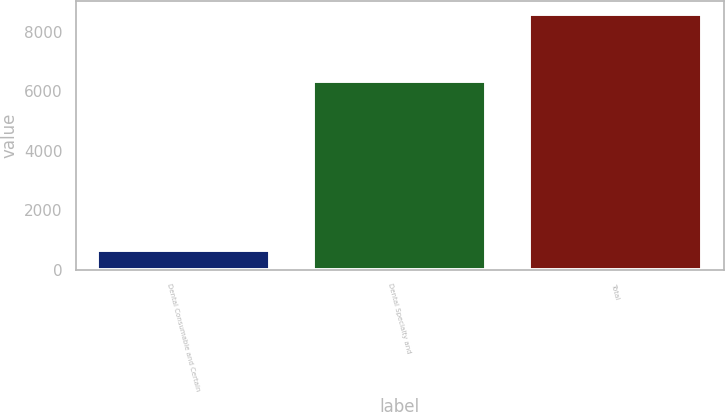<chart> <loc_0><loc_0><loc_500><loc_500><bar_chart><fcel>Dental Consumable and Certain<fcel>Dental Specialty and<fcel>Total<nl><fcel>656<fcel>6333<fcel>8608<nl></chart> 